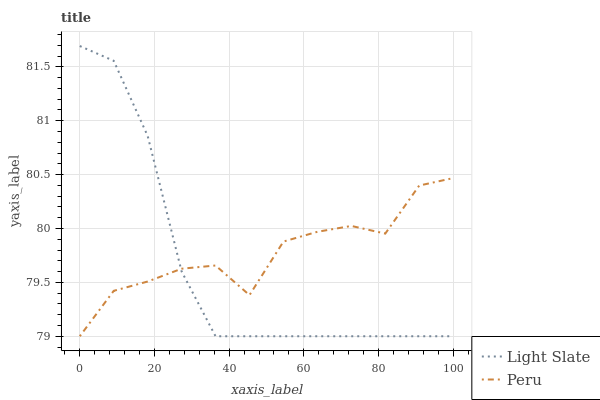Does Light Slate have the minimum area under the curve?
Answer yes or no. Yes. Does Peru have the maximum area under the curve?
Answer yes or no. Yes. Does Peru have the minimum area under the curve?
Answer yes or no. No. Is Light Slate the smoothest?
Answer yes or no. Yes. Is Peru the roughest?
Answer yes or no. Yes. Is Peru the smoothest?
Answer yes or no. No. Does Light Slate have the lowest value?
Answer yes or no. Yes. Does Light Slate have the highest value?
Answer yes or no. Yes. Does Peru have the highest value?
Answer yes or no. No. Does Light Slate intersect Peru?
Answer yes or no. Yes. Is Light Slate less than Peru?
Answer yes or no. No. Is Light Slate greater than Peru?
Answer yes or no. No. 